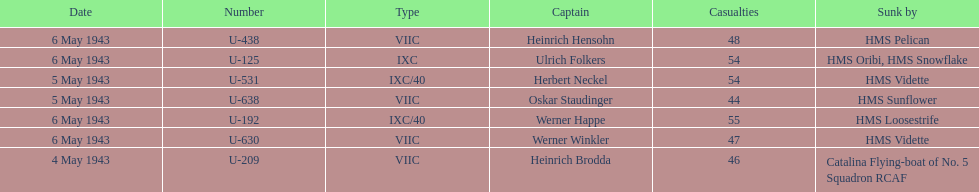Which u-boat was the first to sink U-209. 